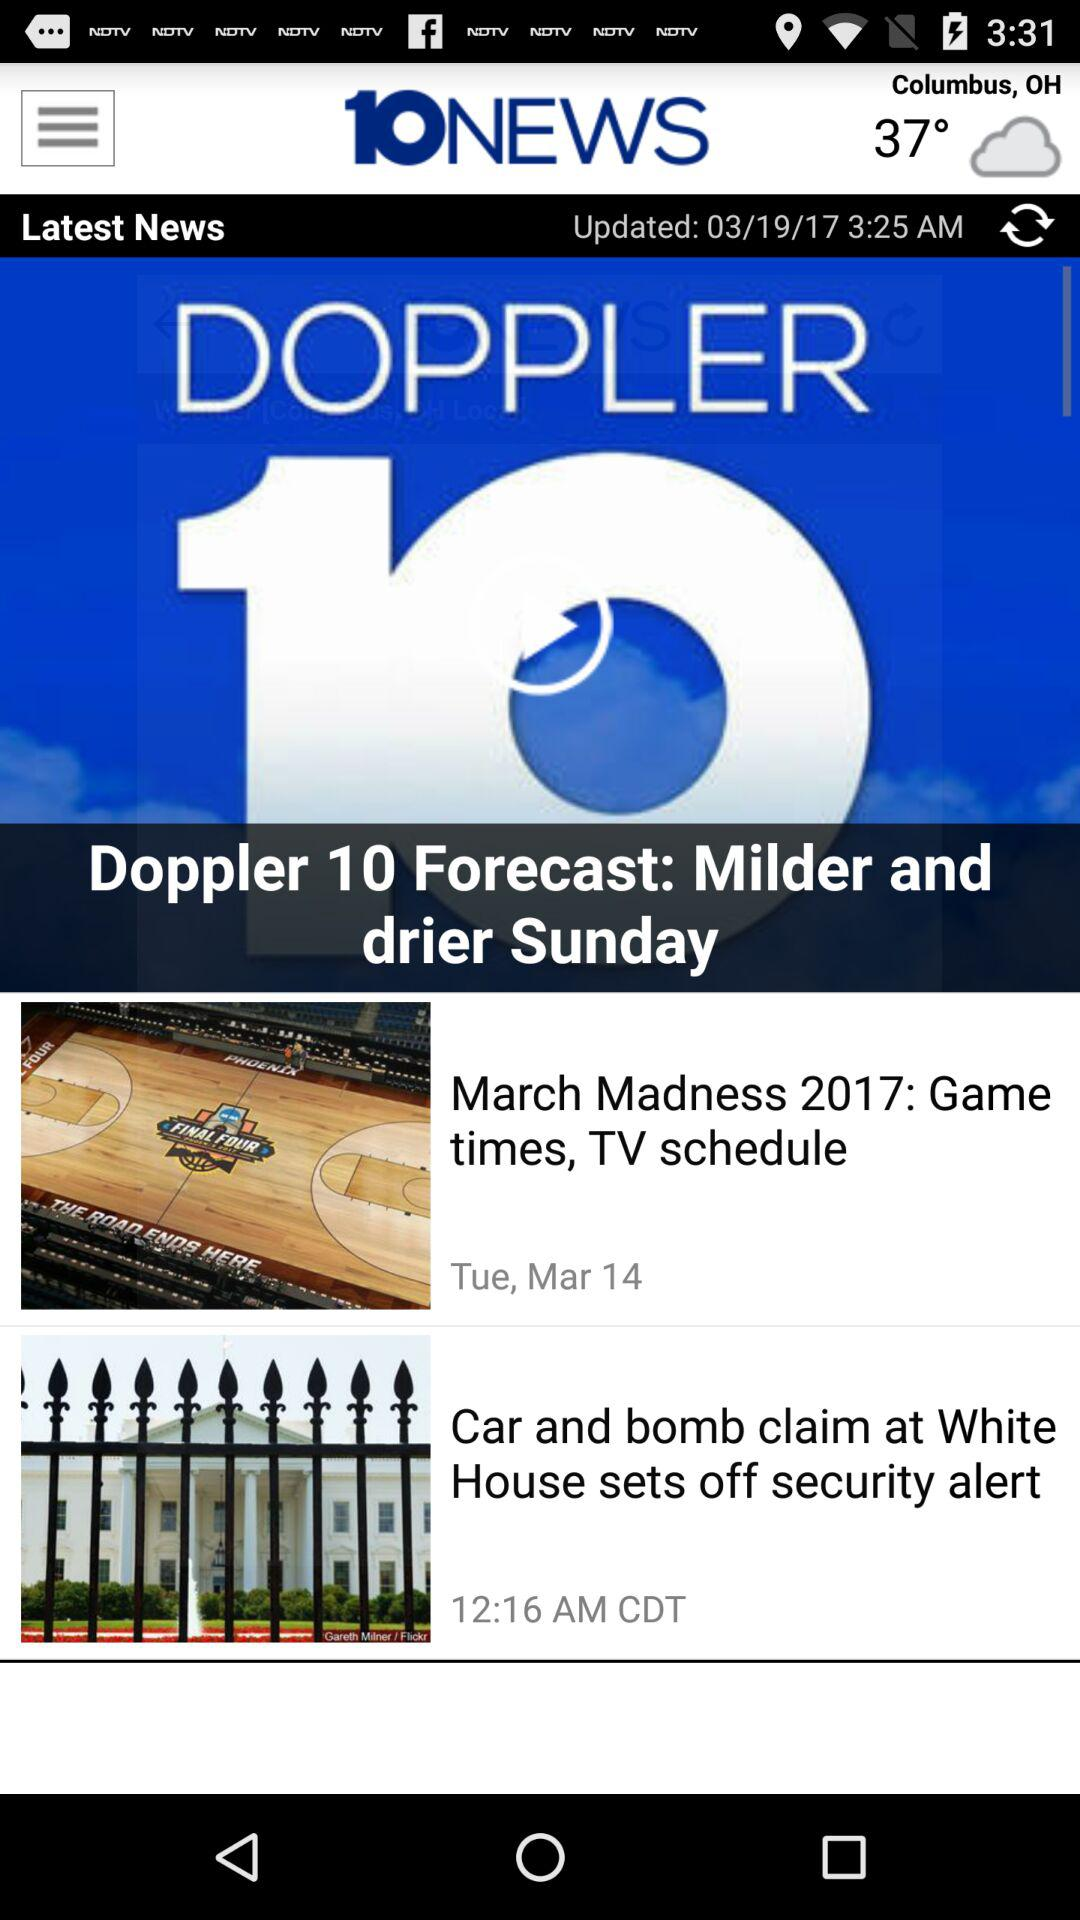What is the temperature? The temperature is 37°. 